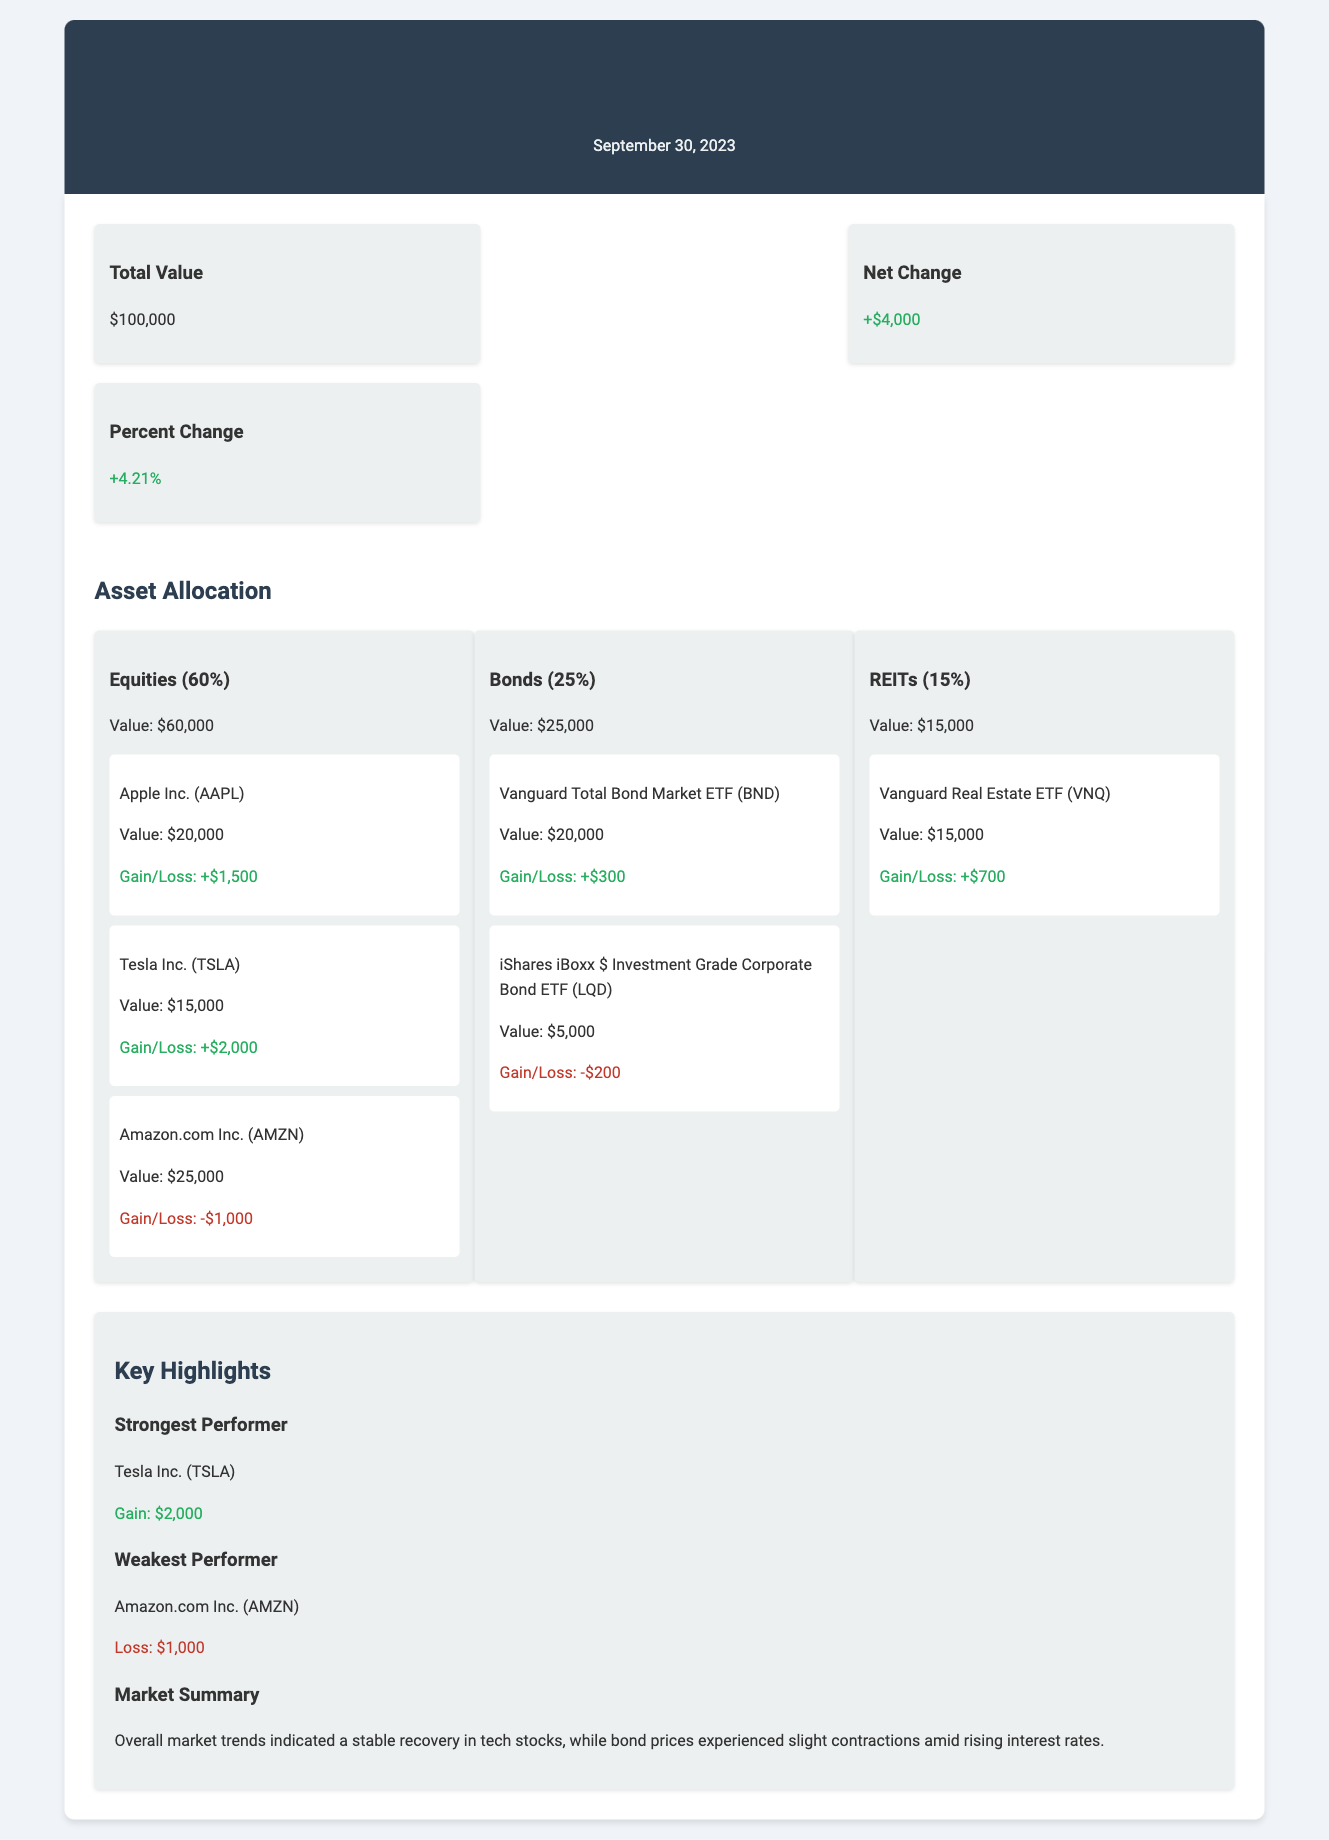What is the total value of the investment portfolio? The total value is explicitly stated in the summary section of the document as $100,000.
Answer: $100,000 What was the net change in the investment portfolio for September 2023? The net change is found in the summary section and is reported as +$4,000.
Answer: +$4,000 What is the percent change of the portfolio this month? The percent change is also provided in the summary, which indicates a change of +4.21%.
Answer: +4.21% Which asset had the highest gain? The strongest performer is highlighted in the key highlights section as Tesla Inc. (TSLA) with a gain of $2,000.
Answer: Tesla Inc. (TSLA) What percentage of the portfolio is allocated to bonds? The asset allocation clearly shows that bonds make up 25% of the total portfolio.
Answer: 25% What was the loss associated with Amazon.com Inc. (AMZN)? The document specifies that the gain/loss for Amazon.com Inc. is -$1,000.
Answer: -$1,000 How much was the value of the equities in the portfolio? The equities are detailed in the asset allocation section with a total value of $60,000.
Answer: $60,000 Which asset lost value in the bonds category? The notable asset with a loss in the bonds category is iShares iBoxx $ Investment Grade Corporate Bond ETF (LQD) with a loss of -$200.
Answer: iShares iBoxx $ Investment Grade Corporate Bond ETF (LQD) What is the total value of investments in REITs? The value of investments in REITs is clearly specified as $15,000 in the asset allocation section.
Answer: $15,000 